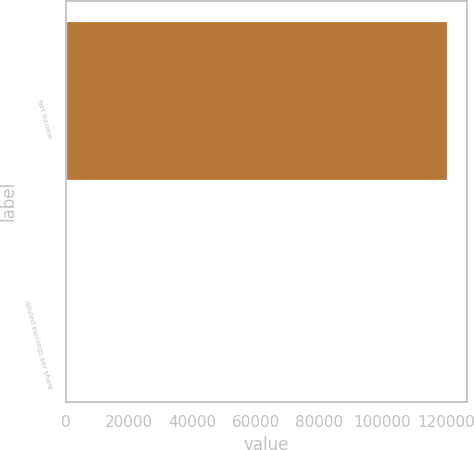<chart> <loc_0><loc_0><loc_500><loc_500><bar_chart><fcel>Net income<fcel>diluted earnings per share<nl><fcel>120643<fcel>1.66<nl></chart> 